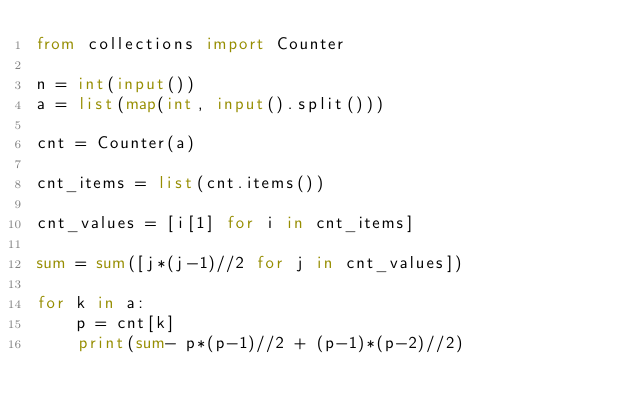Convert code to text. <code><loc_0><loc_0><loc_500><loc_500><_Python_>from collections import Counter

n = int(input())
a = list(map(int, input().split()))

cnt = Counter(a)

cnt_items = list(cnt.items())

cnt_values = [i[1] for i in cnt_items]

sum = sum([j*(j-1)//2 for j in cnt_values])

for k in a:
    p = cnt[k]
    print(sum- p*(p-1)//2 + (p-1)*(p-2)//2)</code> 